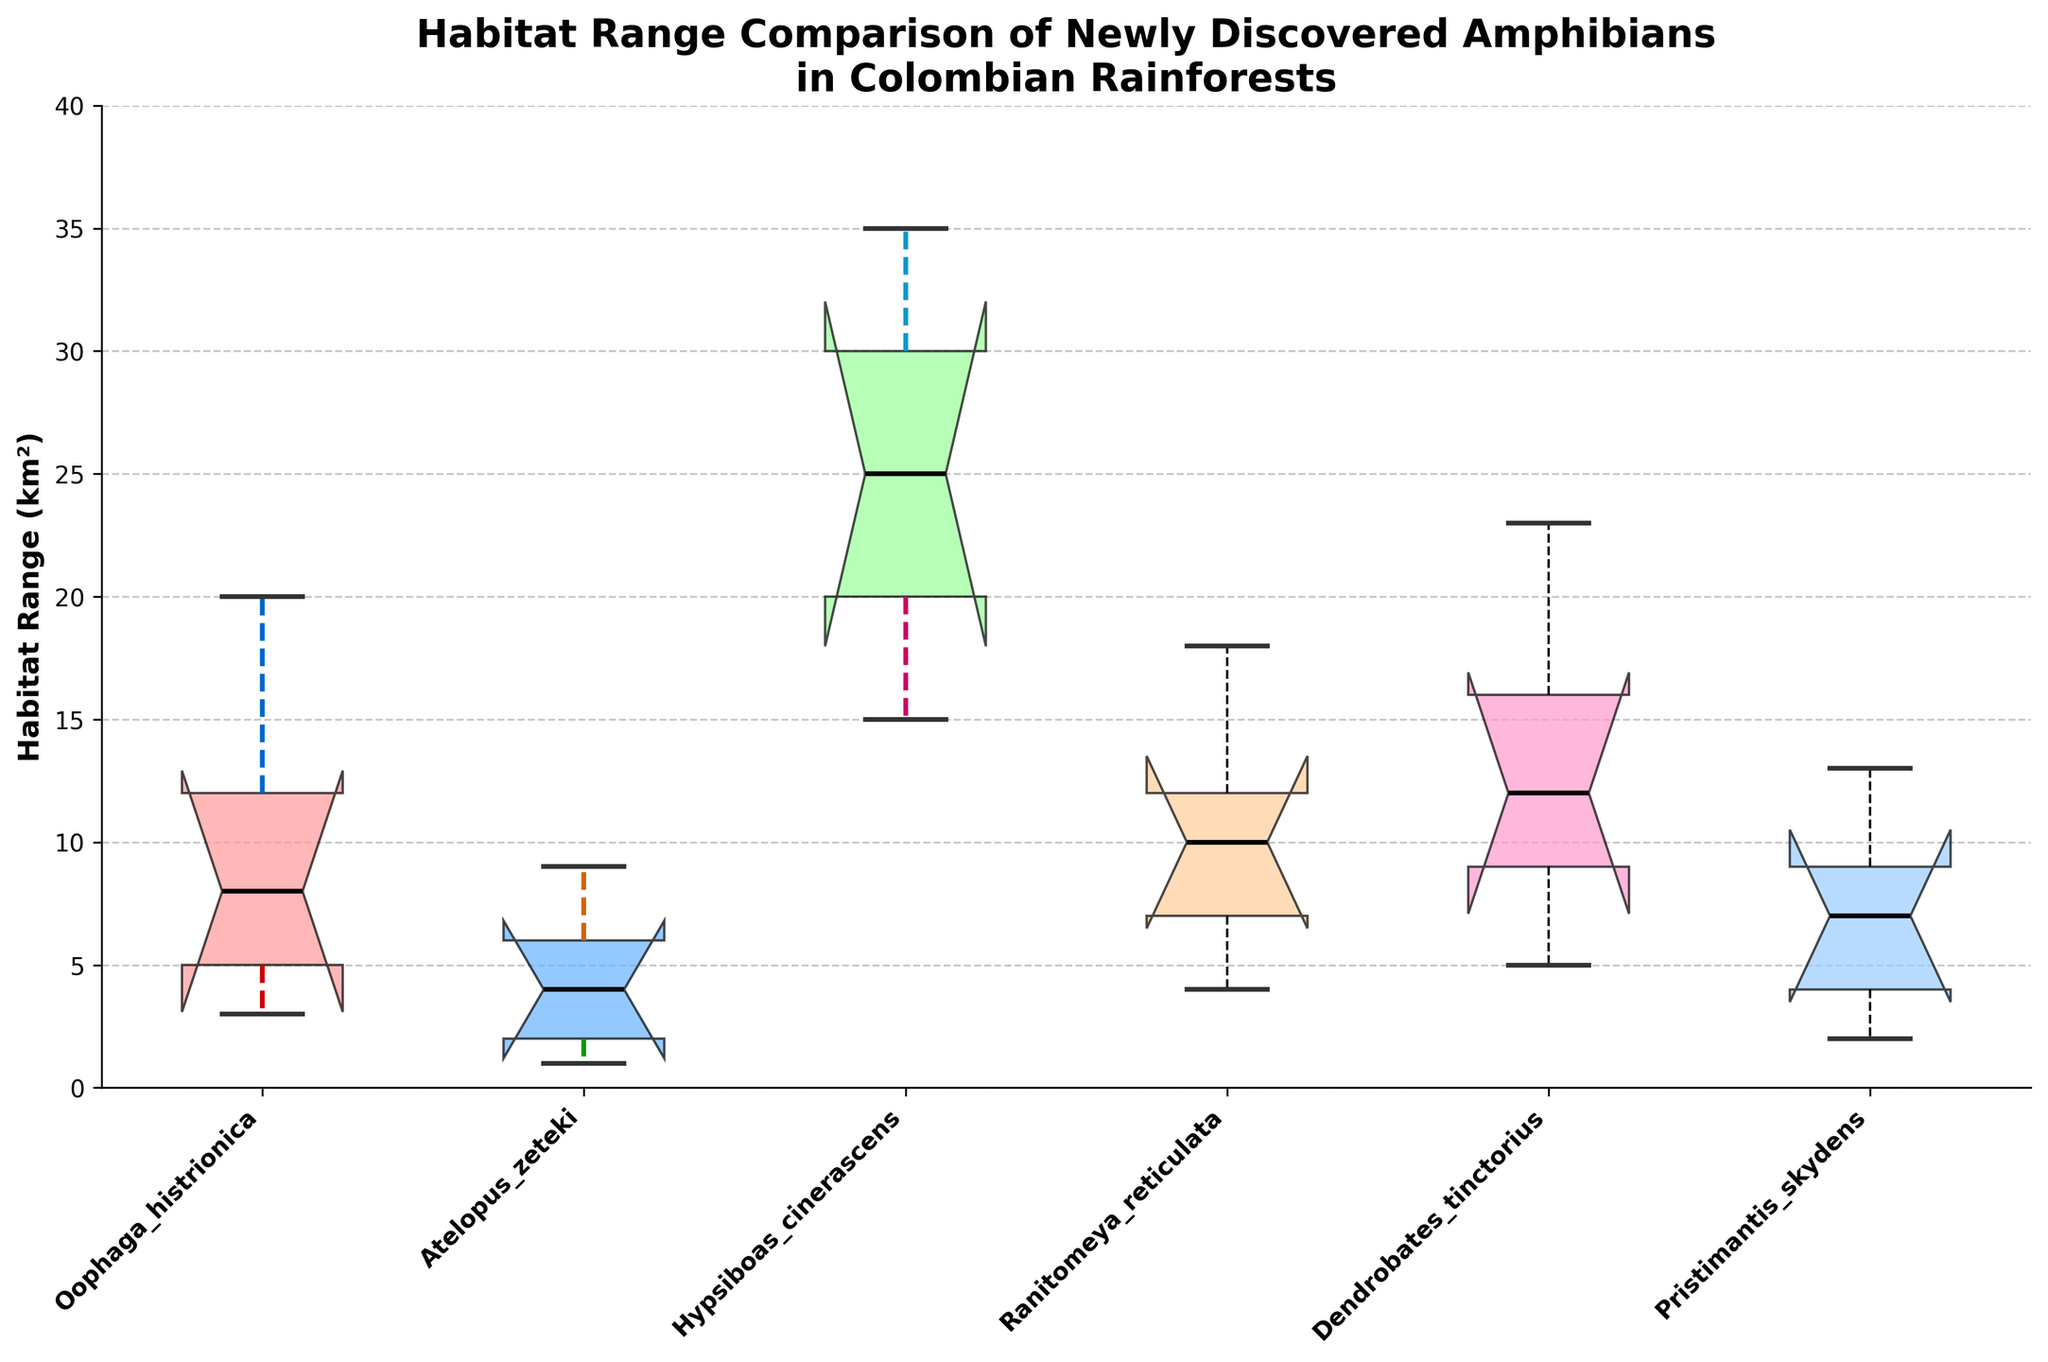What's the median habitat range of Ranitomeya reticulata? Identify the median value shown in the boxplot for Ranitomeya reticulata.
Answer: 10 km² Which species has the largest whisker representing the maximum habitat range? Compare the top whiskers of each species to see which one reaches the highest value.
Answer: Hypsiboas cinerascens Which species has the smallest minimum habitat range? Compare the bottom whiskers of each species to see which one reaches the lowest value.
Answer: Atelopus zeteki What’s the interquartile range (IQR) of Pristimantis skydens? Calculate the difference between the first and third quartiles for Pristimantis skydens. The first quartile is 4 km² and the third quartile is 9 km². So, 9 km² - 4 km² = 5 km².
Answer: 5 km² How many species have a median habitat range greater than 10 km²? Identify species with the median values above 10 km² by examining the boxplot. Only Hypsiboas cinerascens and Dendrobates tinctorius have medians greater than 10 km².
Answer: 2 species Which species has the widest spread in habitat range? Compare the range from the minimum to the maximum value for each species. Hypsiboas cinerascens has the widest spread from 15 km² to 35 km².
Answer: Hypsiboas cinerascens Is the median habitat range of Dendrobates tinctorius greater than the third quartile range of Atelopus zeteki? Compare the median value of Dendrobates tinctorius (12 km²) with the third quartile of Atelopus zeteki (6 km²).
Answer: Yes Which species' habitat range is closer to being symmetrically distributed: Pristimantis skydens or Oophaga histrionica? Check the symmetry of the boxplots by comparing the median's position and the lengths of whiskers for both species. For Pristimantis skydens, the median is closer to the center relative to the spread (2, 4, 7, 9, 13) vs. Oophaga histrionica (3, 5, 8, 12, 20).
Answer: Pristimantis skydens 